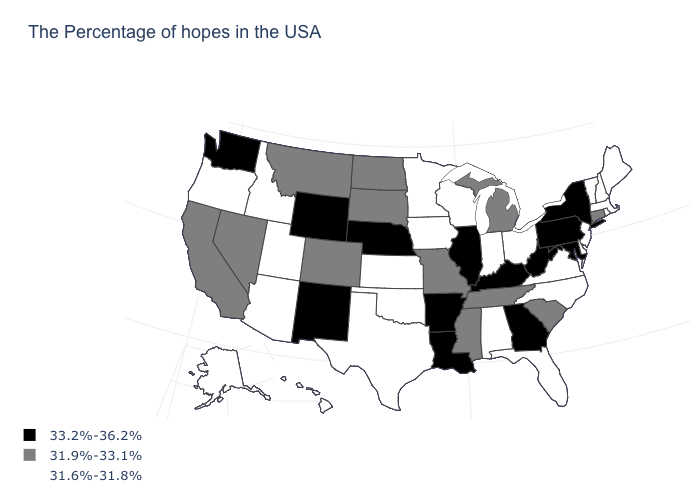Among the states that border Montana , which have the lowest value?
Keep it brief. Idaho. Is the legend a continuous bar?
Give a very brief answer. No. What is the value of Connecticut?
Answer briefly. 31.9%-33.1%. Name the states that have a value in the range 31.9%-33.1%?
Keep it brief. Connecticut, South Carolina, Michigan, Tennessee, Mississippi, Missouri, South Dakota, North Dakota, Colorado, Montana, Nevada, California. Name the states that have a value in the range 31.6%-31.8%?
Short answer required. Maine, Massachusetts, Rhode Island, New Hampshire, Vermont, New Jersey, Delaware, Virginia, North Carolina, Ohio, Florida, Indiana, Alabama, Wisconsin, Minnesota, Iowa, Kansas, Oklahoma, Texas, Utah, Arizona, Idaho, Oregon, Alaska, Hawaii. Name the states that have a value in the range 33.2%-36.2%?
Answer briefly. New York, Maryland, Pennsylvania, West Virginia, Georgia, Kentucky, Illinois, Louisiana, Arkansas, Nebraska, Wyoming, New Mexico, Washington. What is the value of Mississippi?
Write a very short answer. 31.9%-33.1%. Name the states that have a value in the range 33.2%-36.2%?
Quick response, please. New York, Maryland, Pennsylvania, West Virginia, Georgia, Kentucky, Illinois, Louisiana, Arkansas, Nebraska, Wyoming, New Mexico, Washington. What is the lowest value in the South?
Short answer required. 31.6%-31.8%. What is the lowest value in the West?
Answer briefly. 31.6%-31.8%. What is the value of Ohio?
Quick response, please. 31.6%-31.8%. Does Delaware have the lowest value in the South?
Answer briefly. Yes. What is the value of Maryland?
Write a very short answer. 33.2%-36.2%. Does Maryland have a higher value than Georgia?
Write a very short answer. No. What is the value of Alabama?
Keep it brief. 31.6%-31.8%. 